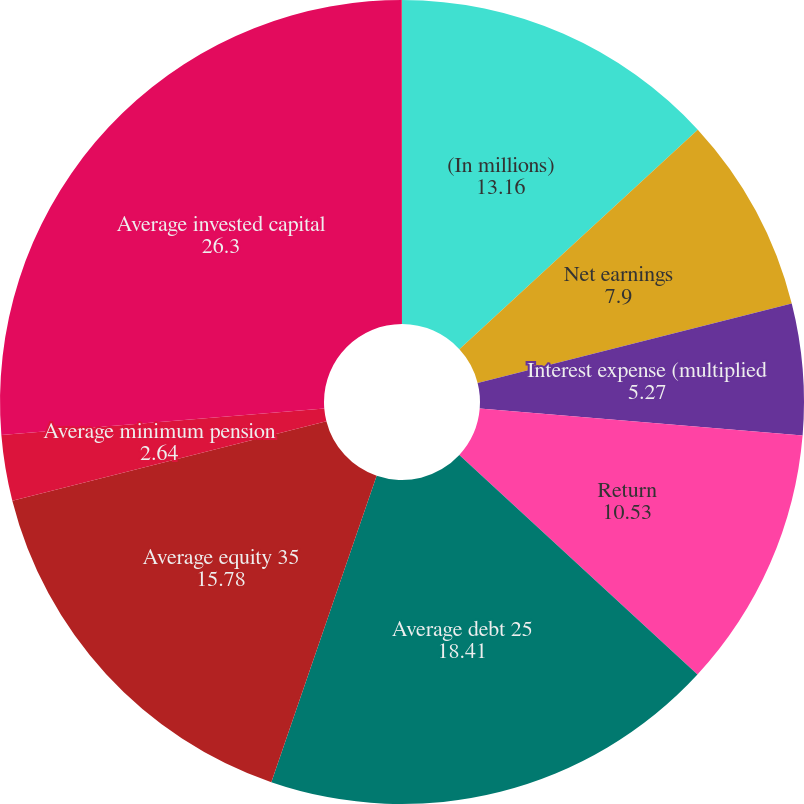Convert chart. <chart><loc_0><loc_0><loc_500><loc_500><pie_chart><fcel>(In millions)<fcel>Net earnings<fcel>Interest expense (multiplied<fcel>Return<fcel>Average debt 25<fcel>Average equity 35<fcel>Average minimum pension<fcel>Average invested capital<fcel>Return on invested capital<nl><fcel>13.16%<fcel>7.9%<fcel>5.27%<fcel>10.53%<fcel>18.41%<fcel>15.78%<fcel>2.64%<fcel>26.3%<fcel>0.01%<nl></chart> 